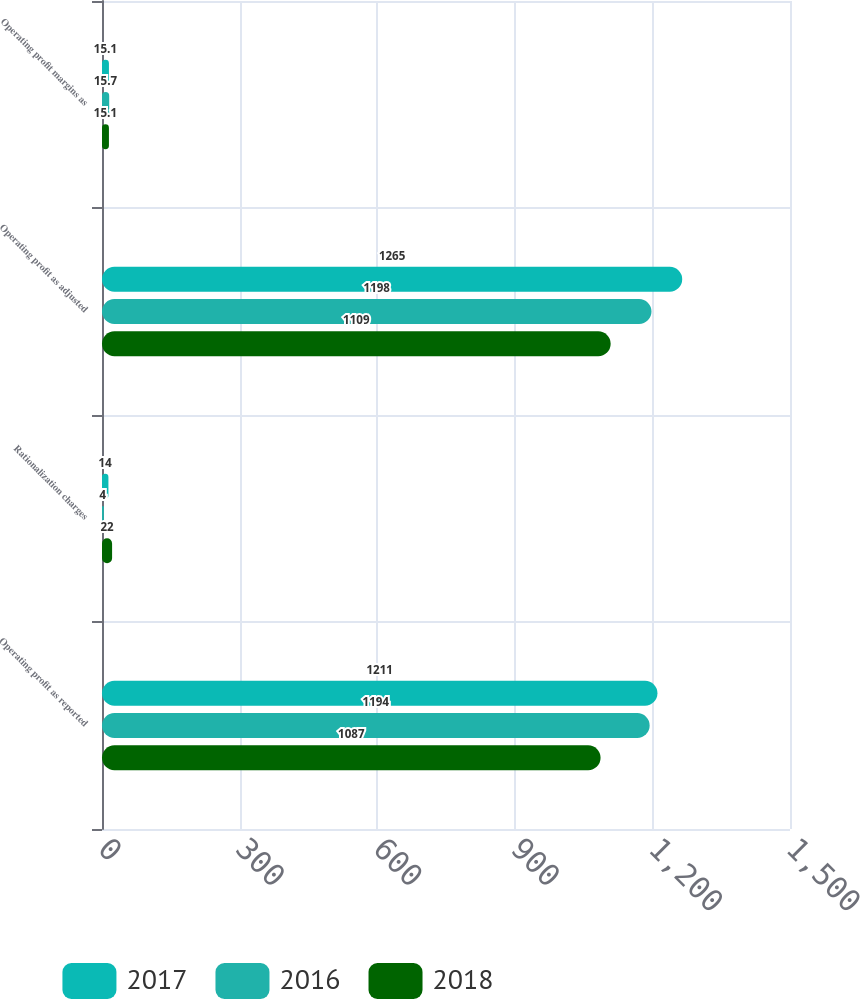<chart> <loc_0><loc_0><loc_500><loc_500><stacked_bar_chart><ecel><fcel>Operating profit as reported<fcel>Rationalization charges<fcel>Operating profit as adjusted<fcel>Operating profit margins as<nl><fcel>2017<fcel>1211<fcel>14<fcel>1265<fcel>15.1<nl><fcel>2016<fcel>1194<fcel>4<fcel>1198<fcel>15.7<nl><fcel>2018<fcel>1087<fcel>22<fcel>1109<fcel>15.1<nl></chart> 